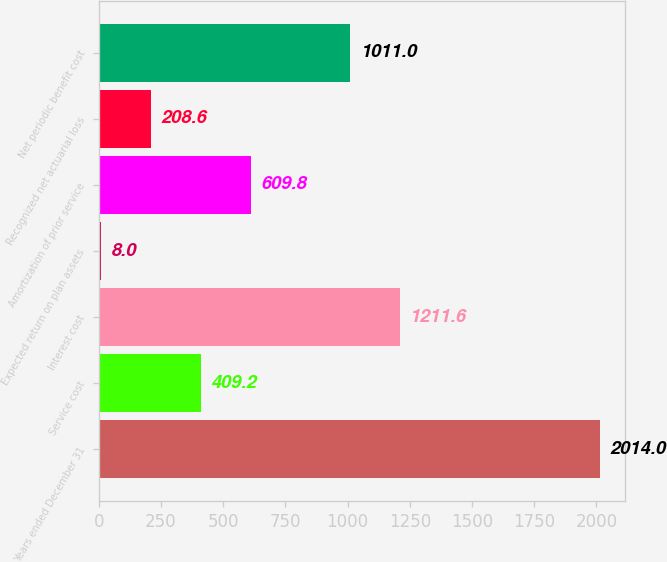Convert chart. <chart><loc_0><loc_0><loc_500><loc_500><bar_chart><fcel>Years ended December 31<fcel>Service cost<fcel>Interest cost<fcel>Expected return on plan assets<fcel>Amortization of prior service<fcel>Recognized net actuarial loss<fcel>Net periodic benefit cost<nl><fcel>2014<fcel>409.2<fcel>1211.6<fcel>8<fcel>609.8<fcel>208.6<fcel>1011<nl></chart> 